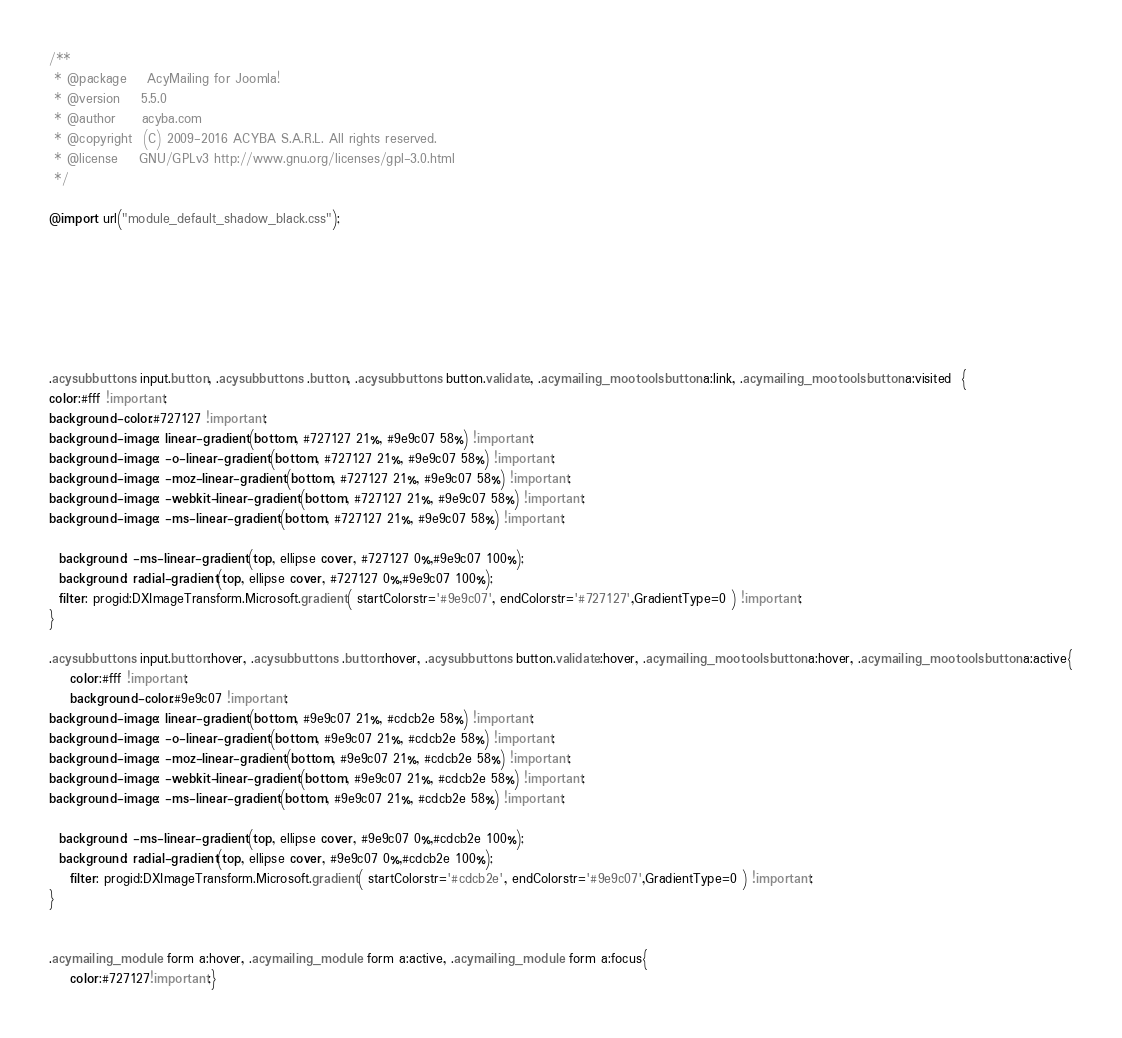Convert code to text. <code><loc_0><loc_0><loc_500><loc_500><_CSS_>/**
 * @package    AcyMailing for Joomla!
 * @version    5.5.0
 * @author     acyba.com
 * @copyright  (C) 2009-2016 ACYBA S.A.R.L. All rights reserved.
 * @license    GNU/GPLv3 http://www.gnu.org/licenses/gpl-3.0.html
 */

@import url("module_default_shadow_black.css");







.acysubbuttons input.button, .acysubbuttons .button, .acysubbuttons button.validate, .acymailing_mootoolsbutton a:link, .acymailing_mootoolsbutton a:visited  {
color:#fff !important;
background-color:#727127 !important;
background-image: linear-gradient(bottom, #727127 21%, #9e9c07 58%) !important;
background-image: -o-linear-gradient(bottom, #727127 21%, #9e9c07 58%) !important;
background-image: -moz-linear-gradient(bottom, #727127 21%, #9e9c07 58%) !important;
background-image: -webkit-linear-gradient(bottom, #727127 21%, #9e9c07 58%) !important;
background-image: -ms-linear-gradient(bottom, #727127 21%, #9e9c07 58%) !important;

  background: -ms-linear-gradient(top, ellipse cover, #727127 0%,#9e9c07 100%); 
  background: radial-gradient(top, ellipse cover, #727127 0%,#9e9c07 100%);
  filter: progid:DXImageTransform.Microsoft.gradient( startColorstr='#9e9c07', endColorstr='#727127',GradientType=0 ) !important; 
}

.acysubbuttons input.button:hover, .acysubbuttons .button:hover, .acysubbuttons button.validate:hover, .acymailing_mootoolsbutton a:hover, .acymailing_mootoolsbutton a:active{
    color:#fff !important;
	background-color:#9e9c07 !important;
background-image: linear-gradient(bottom, #9e9c07 21%, #cdcb2e 58%) !important;
background-image: -o-linear-gradient(bottom, #9e9c07 21%, #cdcb2e 58%) !important;
background-image: -moz-linear-gradient(bottom, #9e9c07 21%, #cdcb2e 58%) !important;
background-image: -webkit-linear-gradient(bottom, #9e9c07 21%, #cdcb2e 58%) !important;
background-image: -ms-linear-gradient(bottom, #9e9c07 21%, #cdcb2e 58%) !important;

  background: -ms-linear-gradient(top, ellipse cover, #9e9c07 0%,#cdcb2e 100%); 
  background: radial-gradient(top, ellipse cover, #9e9c07 0%,#cdcb2e 100%);
    filter: progid:DXImageTransform.Microsoft.gradient( startColorstr='#cdcb2e', endColorstr='#9e9c07',GradientType=0 ) !important; 
}


.acymailing_module form a:hover, .acymailing_module form a:active, .acymailing_module form a:focus{
	color:#727127!important;}
</code> 